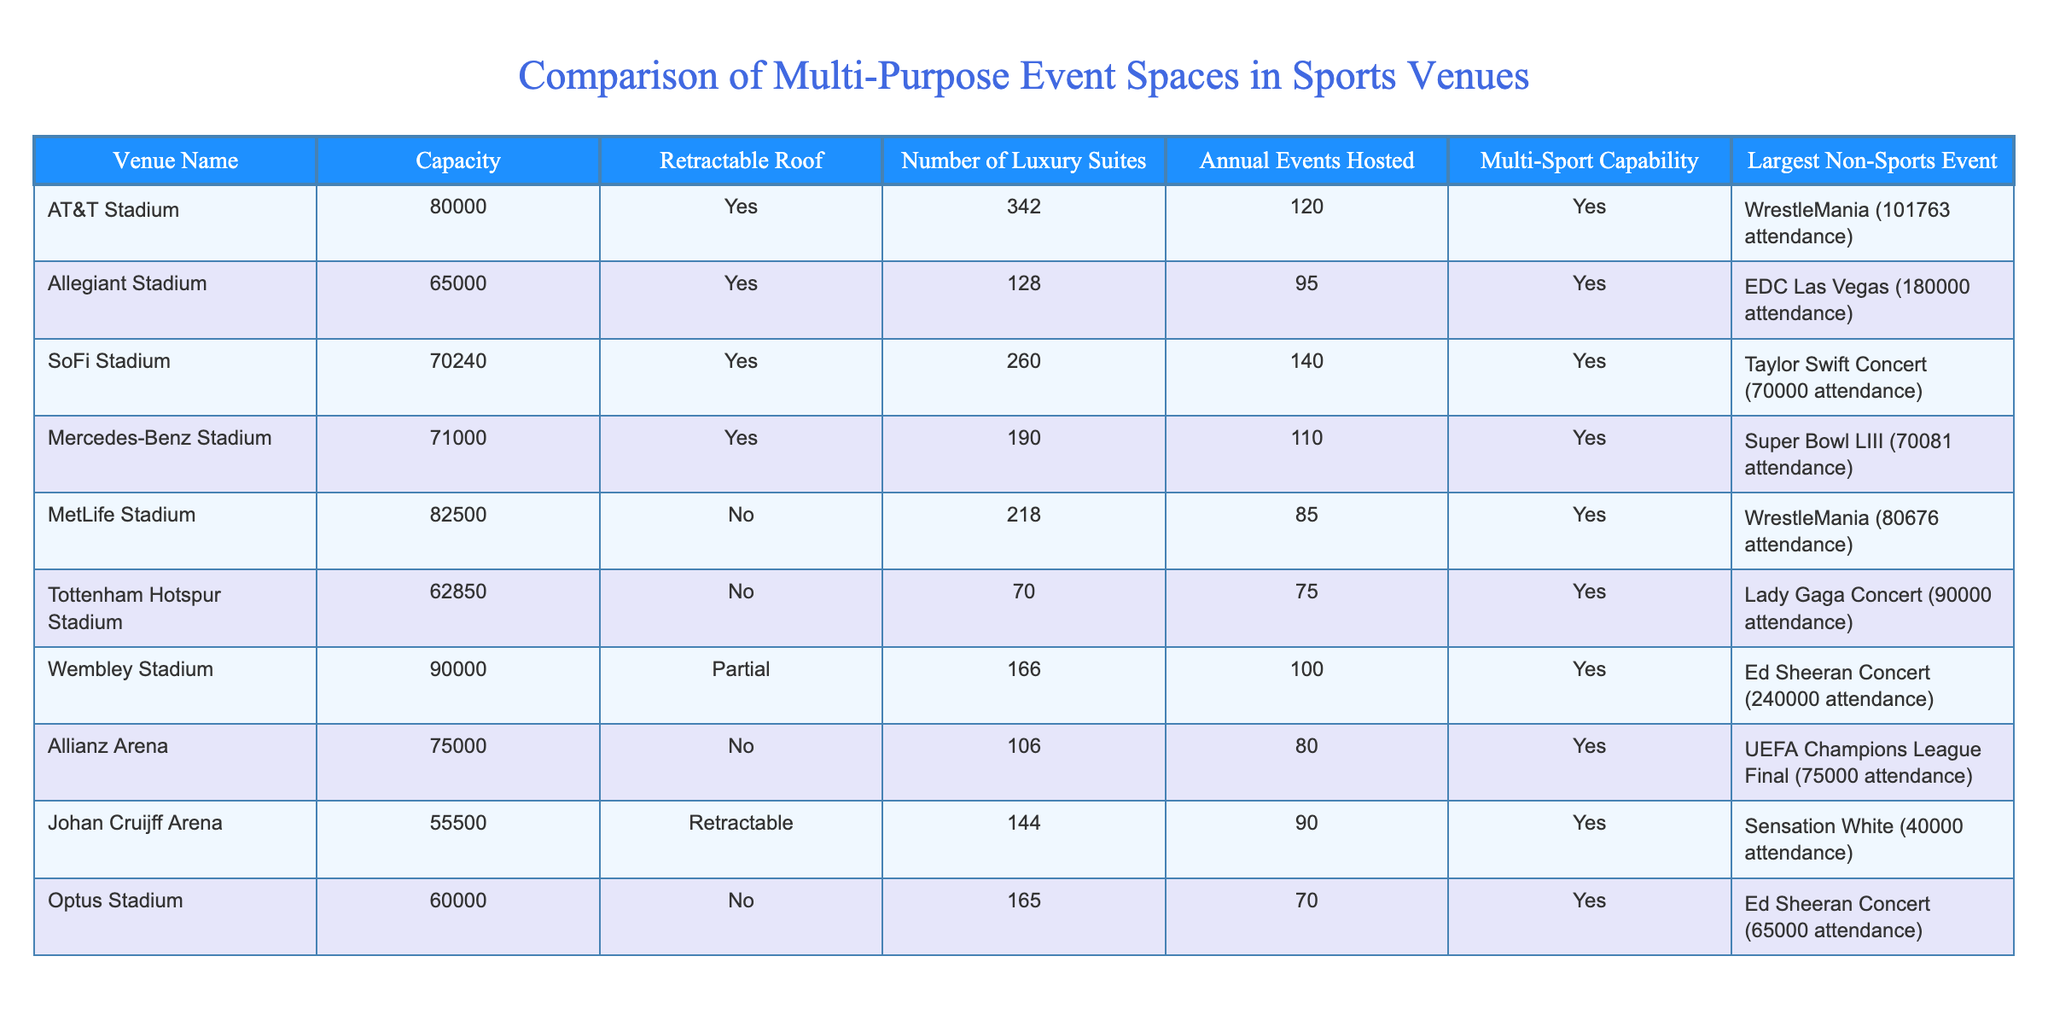What is the capacity of Wembley Stadium? The capacity of Wembley Stadium is listed in the table, which shows a value of 90000.
Answer: 90000 Which venue has the most luxury suites? By examining the "Number of Luxury Suites" column, AT&T Stadium has the highest number with 342 suites.
Answer: 342 Is Allegiant Stadium multi-sport capable? Checking the "Multi-Sport Capability" column, it shows 'Yes' for Allegiant Stadium, indicating it can host multiple sports.
Answer: Yes What is the total capacity of the top three largest venues? The capacities of the top three venues are 90000 (Wembley), 82500 (MetLife), and 80000 (AT&T). Summing these gives 90000 + 82500 + 80000 = 252500.
Answer: 252500 Which venue hosted the largest non-sports event? From the "Largest Non-Sports Event" column, Wembley Stadium hosted Ed Sheeran Concert with an attendance of 240000, which is the highest attendance recorded.
Answer: Wembley Stadium Do all venues with a retractable roof have multi-sport capabilities? This requires checking both the "Retractable Roof" and the "Multi-Sport Capability" columns. Johan Cruijff Arena has a retractable roof and is multi-sport capable; however, some venues with retractable roofs do not specifically state that they have hosted multi-sport events, indicating variability.
Answer: No What is the average number of annual events hosted by the venues? To find the average, sum the annual events hosted (120 + 95 + 140 + 110 + 85 + 75 + 100 + 80 + 90 + 70 = 1005) and divide by the number of venues (10). The average is 1005 / 10 = 100.5.
Answer: 100.5 Which venue has the lowest capacity, and what is that capacity? The "Capacity" column shows Johan Cruijff Arena with a capacity of 55500, indicating it has the lowest among all listed venues.
Answer: 55500 What percentage of venues have luxury suites? There are 10 venues, and 7 of them have a "Number of Luxury Suites" greater than 0. Thus, the percentage is (7/10) * 100 = 70%.
Answer: 70% 